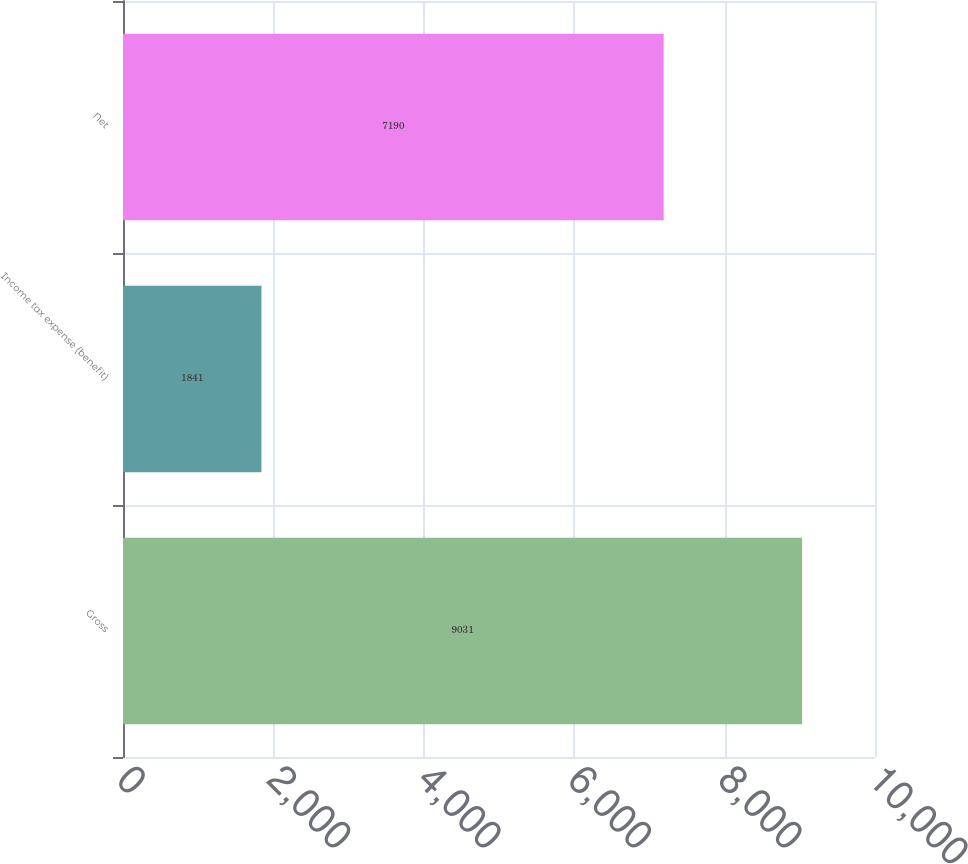Convert chart. <chart><loc_0><loc_0><loc_500><loc_500><bar_chart><fcel>Gross<fcel>Income tax expense (benefit)<fcel>Net<nl><fcel>9031<fcel>1841<fcel>7190<nl></chart> 